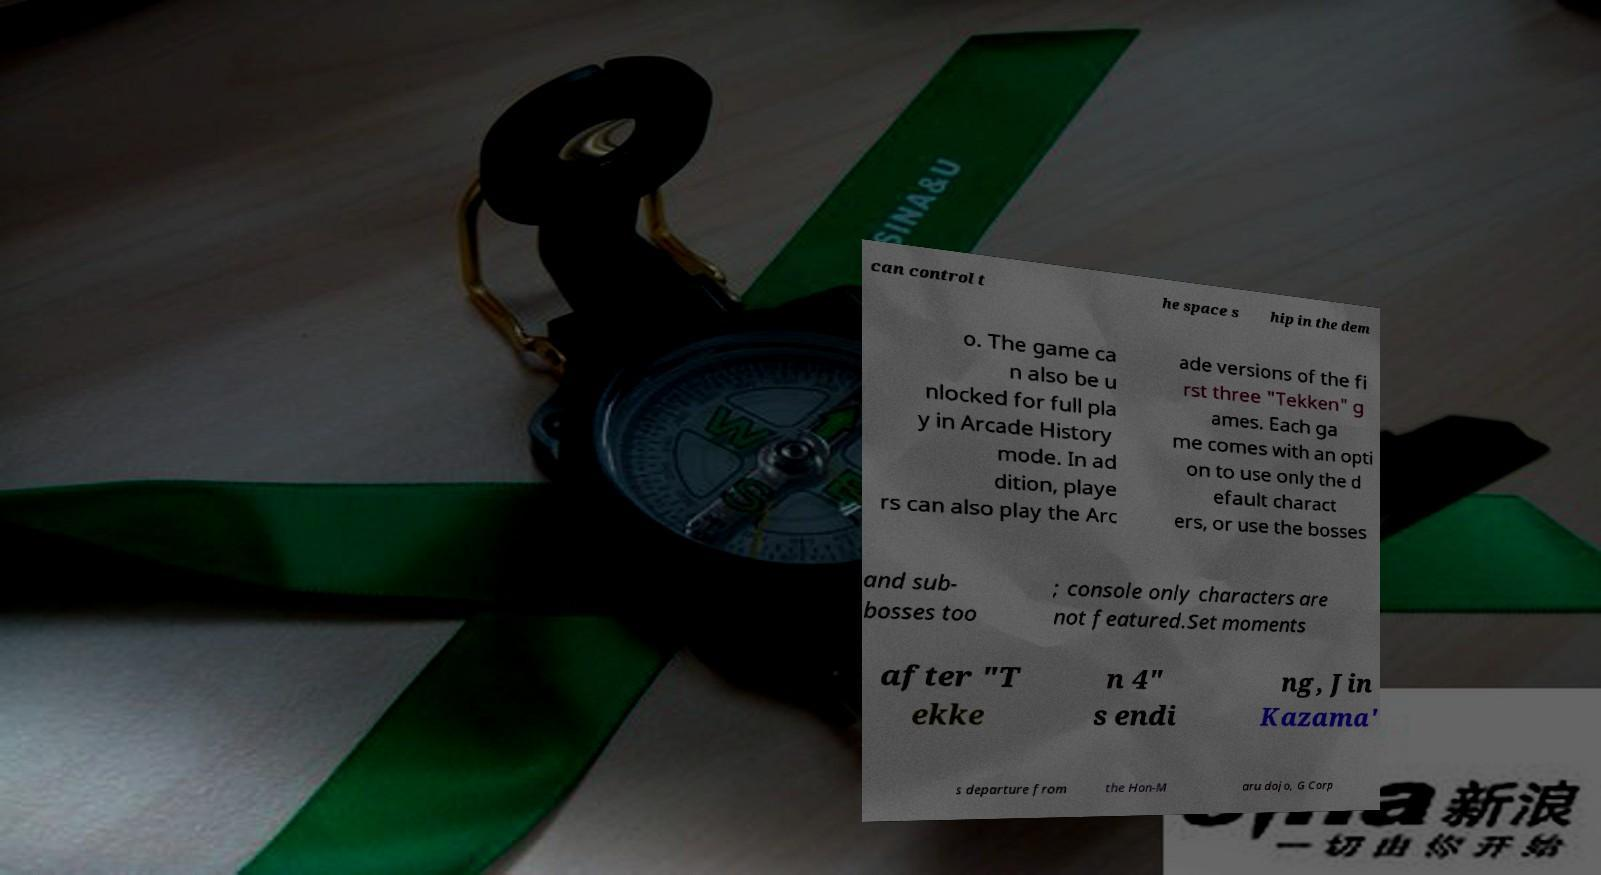For documentation purposes, I need the text within this image transcribed. Could you provide that? can control t he space s hip in the dem o. The game ca n also be u nlocked for full pla y in Arcade History mode. In ad dition, playe rs can also play the Arc ade versions of the fi rst three "Tekken" g ames. Each ga me comes with an opti on to use only the d efault charact ers, or use the bosses and sub- bosses too ; console only characters are not featured.Set moments after "T ekke n 4" s endi ng, Jin Kazama' s departure from the Hon-M aru dojo, G Corp 